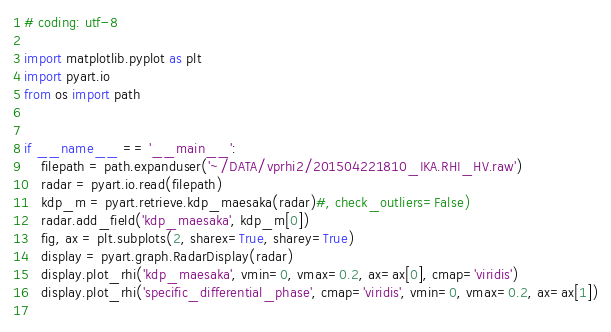<code> <loc_0><loc_0><loc_500><loc_500><_Python_># coding: utf-8

import matplotlib.pyplot as plt
import pyart.io
from os import path


if __name__ == '__main__':
    filepath = path.expanduser('~/DATA/vprhi2/201504221810_IKA.RHI_HV.raw')
    radar = pyart.io.read(filepath)
    kdp_m = pyart.retrieve.kdp_maesaka(radar)#, check_outliers=False)
    radar.add_field('kdp_maesaka', kdp_m[0])
    fig, ax = plt.subplots(2, sharex=True, sharey=True)
    display = pyart.graph.RadarDisplay(radar)
    display.plot_rhi('kdp_maesaka', vmin=0, vmax=0.2, ax=ax[0], cmap='viridis')
    display.plot_rhi('specific_differential_phase', cmap='viridis', vmin=0, vmax=0.2, ax=ax[1])
    </code> 